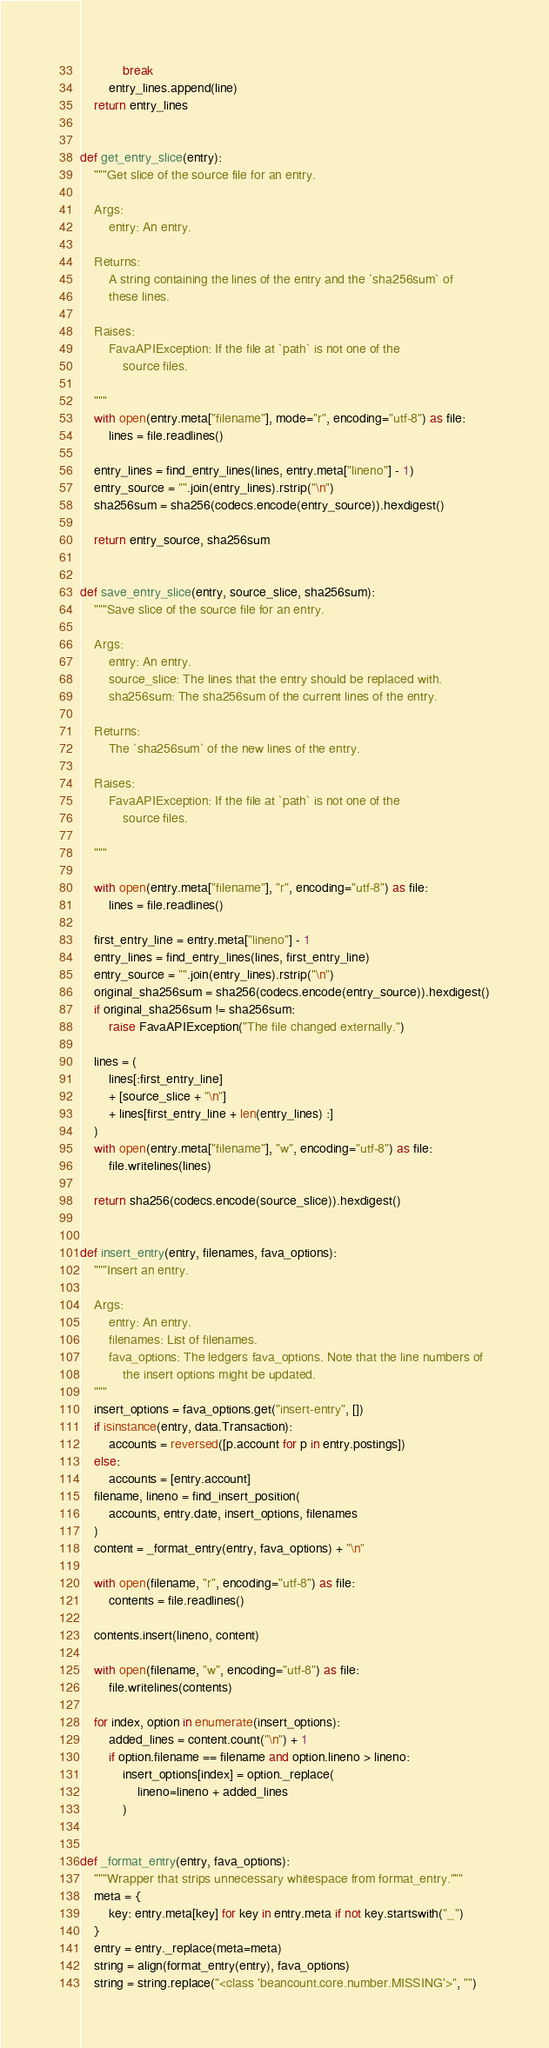<code> <loc_0><loc_0><loc_500><loc_500><_Python_>            break
        entry_lines.append(line)
    return entry_lines


def get_entry_slice(entry):
    """Get slice of the source file for an entry.

    Args:
        entry: An entry.

    Returns:
        A string containing the lines of the entry and the `sha256sum` of
        these lines.

    Raises:
        FavaAPIException: If the file at `path` is not one of the
            source files.

    """
    with open(entry.meta["filename"], mode="r", encoding="utf-8") as file:
        lines = file.readlines()

    entry_lines = find_entry_lines(lines, entry.meta["lineno"] - 1)
    entry_source = "".join(entry_lines).rstrip("\n")
    sha256sum = sha256(codecs.encode(entry_source)).hexdigest()

    return entry_source, sha256sum


def save_entry_slice(entry, source_slice, sha256sum):
    """Save slice of the source file for an entry.

    Args:
        entry: An entry.
        source_slice: The lines that the entry should be replaced with.
        sha256sum: The sha256sum of the current lines of the entry.

    Returns:
        The `sha256sum` of the new lines of the entry.

    Raises:
        FavaAPIException: If the file at `path` is not one of the
            source files.

    """

    with open(entry.meta["filename"], "r", encoding="utf-8") as file:
        lines = file.readlines()

    first_entry_line = entry.meta["lineno"] - 1
    entry_lines = find_entry_lines(lines, first_entry_line)
    entry_source = "".join(entry_lines).rstrip("\n")
    original_sha256sum = sha256(codecs.encode(entry_source)).hexdigest()
    if original_sha256sum != sha256sum:
        raise FavaAPIException("The file changed externally.")

    lines = (
        lines[:first_entry_line]
        + [source_slice + "\n"]
        + lines[first_entry_line + len(entry_lines) :]
    )
    with open(entry.meta["filename"], "w", encoding="utf-8") as file:
        file.writelines(lines)

    return sha256(codecs.encode(source_slice)).hexdigest()


def insert_entry(entry, filenames, fava_options):
    """Insert an entry.

    Args:
        entry: An entry.
        filenames: List of filenames.
        fava_options: The ledgers fava_options. Note that the line numbers of
            the insert options might be updated.
    """
    insert_options = fava_options.get("insert-entry", [])
    if isinstance(entry, data.Transaction):
        accounts = reversed([p.account for p in entry.postings])
    else:
        accounts = [entry.account]
    filename, lineno = find_insert_position(
        accounts, entry.date, insert_options, filenames
    )
    content = _format_entry(entry, fava_options) + "\n"

    with open(filename, "r", encoding="utf-8") as file:
        contents = file.readlines()

    contents.insert(lineno, content)

    with open(filename, "w", encoding="utf-8") as file:
        file.writelines(contents)

    for index, option in enumerate(insert_options):
        added_lines = content.count("\n") + 1
        if option.filename == filename and option.lineno > lineno:
            insert_options[index] = option._replace(
                lineno=lineno + added_lines
            )


def _format_entry(entry, fava_options):
    """Wrapper that strips unnecessary whitespace from format_entry."""
    meta = {
        key: entry.meta[key] for key in entry.meta if not key.startswith("_")
    }
    entry = entry._replace(meta=meta)
    string = align(format_entry(entry), fava_options)
    string = string.replace("<class 'beancount.core.number.MISSING'>", "")</code> 